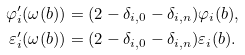<formula> <loc_0><loc_0><loc_500><loc_500>\varphi _ { i } ^ { \prime } ( \omega ( b ) ) & = ( 2 - \delta _ { i , 0 } - \delta _ { i , n } ) \varphi _ { i } ( b ) , \\ \varepsilon _ { i } ^ { \prime } ( \omega ( b ) ) & = ( 2 - \delta _ { i , 0 } - \delta _ { i , n } ) \varepsilon _ { i } ( b ) .</formula> 